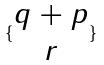Convert formula to latex. <formula><loc_0><loc_0><loc_500><loc_500>\{ \begin{matrix} q + p \\ r \end{matrix} \}</formula> 